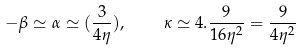<formula> <loc_0><loc_0><loc_500><loc_500>- \beta \simeq \alpha \simeq ( \frac { 3 } { 4 \eta } ) , \quad \kappa \simeq 4 . \frac { 9 } { 1 6 \eta ^ { 2 } } = \frac { 9 } { 4 \eta ^ { 2 } }</formula> 